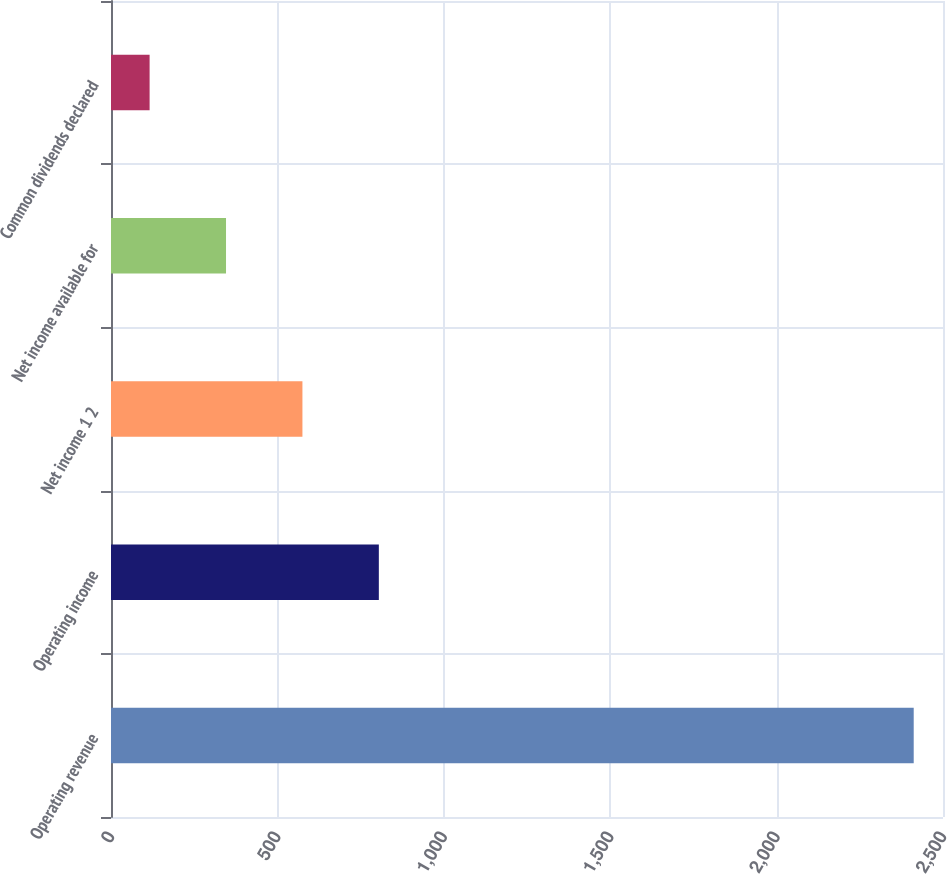Convert chart. <chart><loc_0><loc_0><loc_500><loc_500><bar_chart><fcel>Operating revenue<fcel>Operating income<fcel>Net income 1 2<fcel>Net income available for<fcel>Common dividends declared<nl><fcel>2412<fcel>804.8<fcel>575.2<fcel>345.6<fcel>116<nl></chart> 